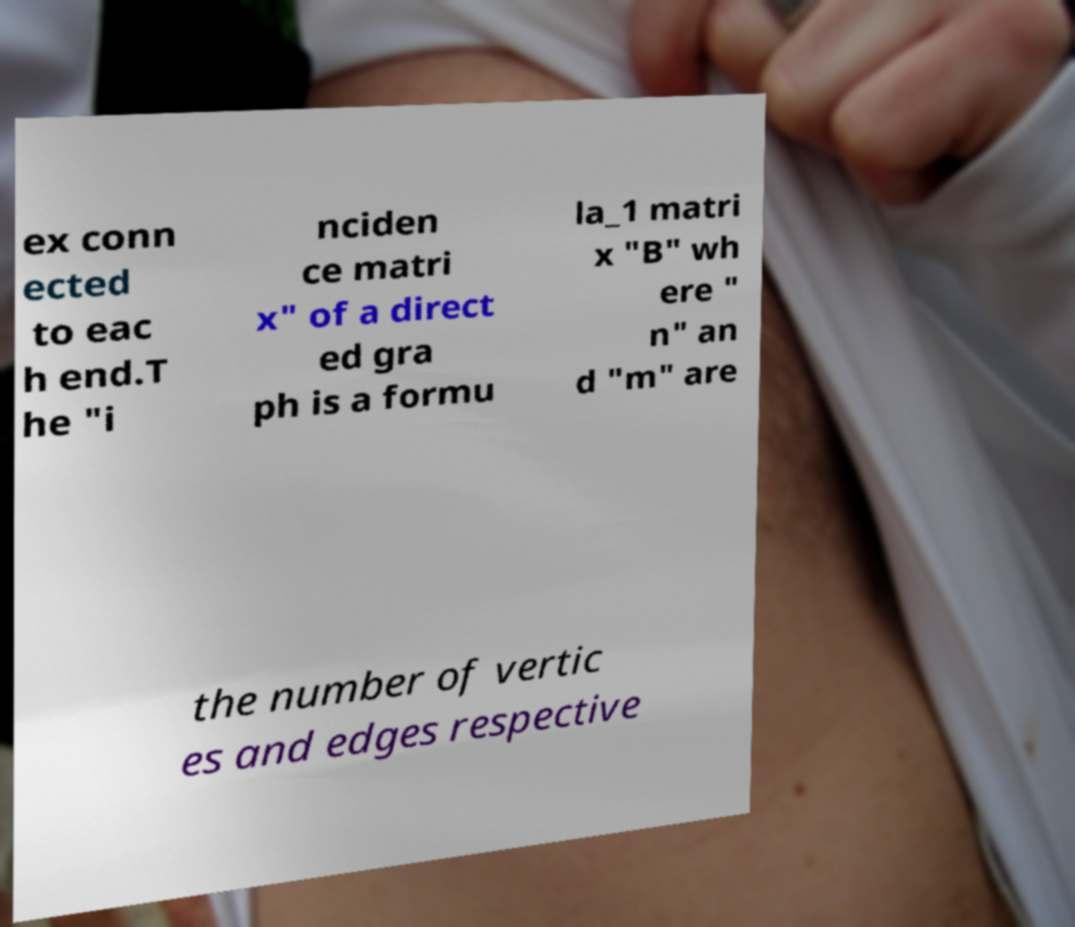Can you accurately transcribe the text from the provided image for me? ex conn ected to eac h end.T he "i nciden ce matri x" of a direct ed gra ph is a formu la_1 matri x "B" wh ere " n" an d "m" are the number of vertic es and edges respective 